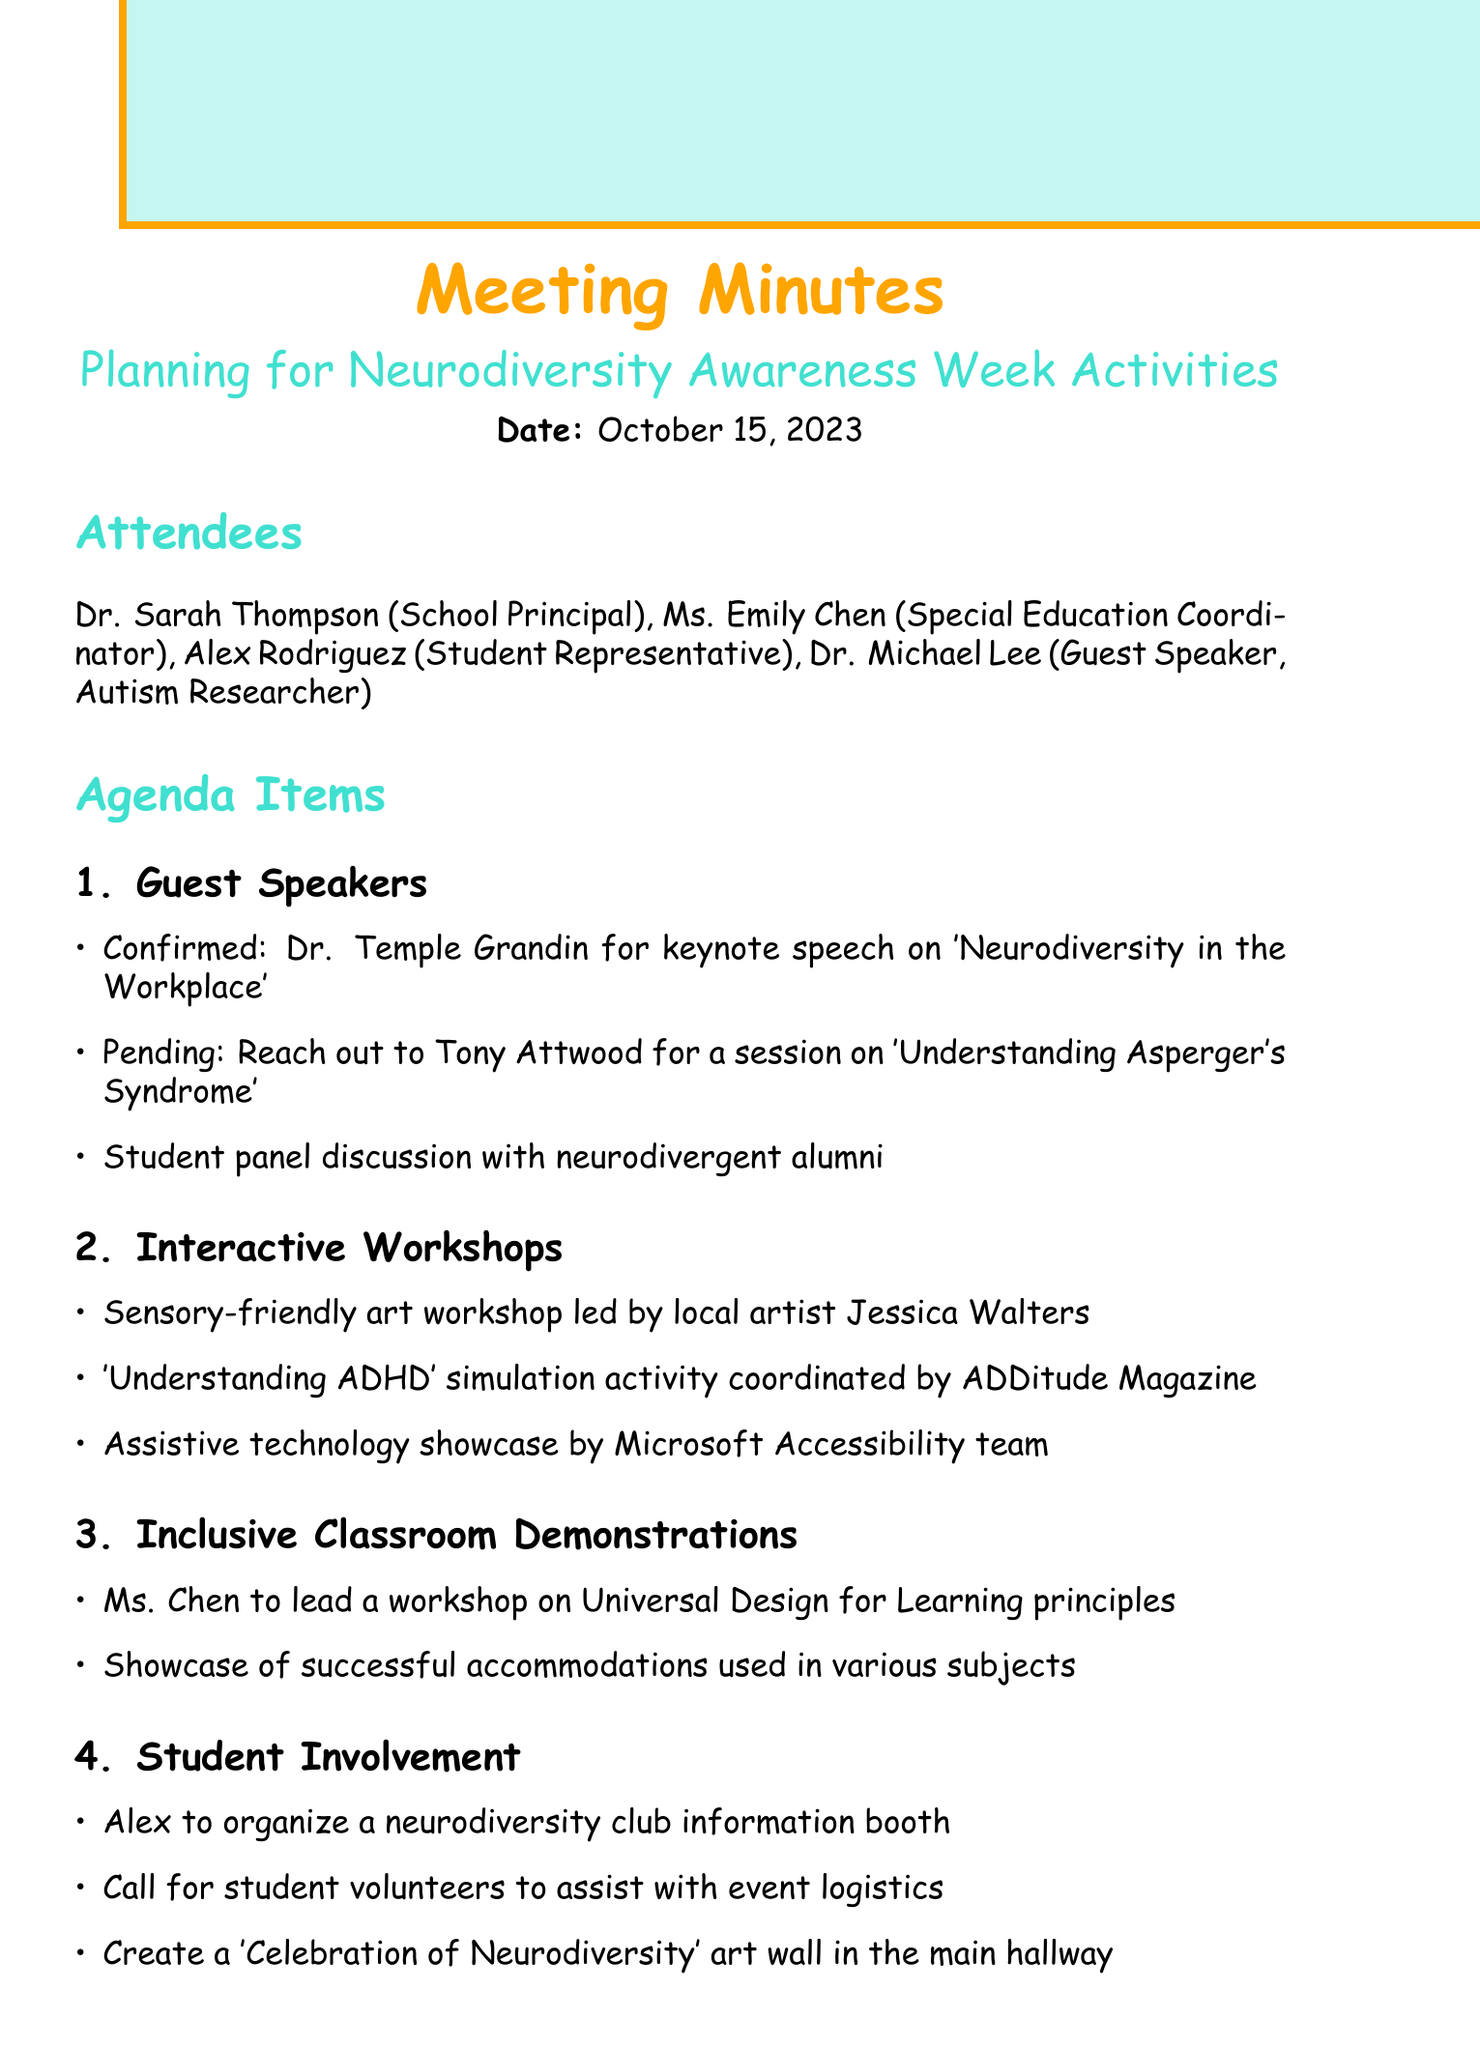What is the meeting date? The meeting date is explicitly stated in the document, which is October 15, 2023.
Answer: October 15, 2023 Who is confirmed as a guest speaker? The document lists Dr. Temple Grandin as the confirmed guest speaker for the keynote speech.
Answer: Dr. Temple Grandin What is the title of Dr. Temple Grandin's speech? The title of Dr. Temple Grandin's speech is mentioned in the agenda and focuses on 'Neurodiversity in the Workplace'.
Answer: Neurodiversity in the Workplace What workshop will be led by Jessica Walters? The document notes that a sensory-friendly art workshop will be led by local artist Jessica Walters.
Answer: Sensory-friendly art workshop What is the deadline for finalizing the guest speaker schedule? The action items section specifies the deadline for finalizing the guest speaker schedule is October 22.
Answer: October 22 How many action items are listed in the document? By counting the items in the action items section, there are a total of four action items listed.
Answer: Four What is one activity Alex is organizing? The document states that Alex will organize a neurodiversity club information booth as part of student involvement.
Answer: Neurodiversity club information booth When is the next meeting scheduled? The document specifies that the next meeting will take place on October 30, 2023.
Answer: October 30, 2023 What topic is Ms. Chen leading a workshop on? The agenda mentions that Ms. Chen will lead a workshop on Universal Design for Learning principles.
Answer: Universal Design for Learning principles 